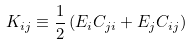Convert formula to latex. <formula><loc_0><loc_0><loc_500><loc_500>K _ { i j } \equiv \frac { 1 } { 2 } \left ( E _ { i } C _ { j i } + E _ { j } C _ { i j } \right )</formula> 